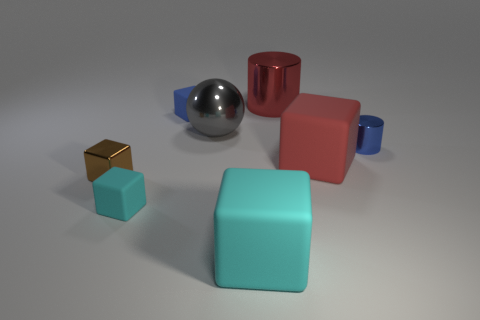Is the color of the shiny ball the same as the large rubber block that is behind the big cyan block?
Ensure brevity in your answer.  No. What number of cylinders are either cyan matte objects or red matte objects?
Your response must be concise. 0. There is a large matte cube left of the large red metal thing; what color is it?
Keep it short and to the point. Cyan. There is a tiny matte thing that is the same color as the tiny metal cylinder; what shape is it?
Offer a very short reply. Cube. How many blue objects have the same size as the sphere?
Your answer should be very brief. 0. Do the big rubber thing that is behind the small cyan cube and the small matte object in front of the brown object have the same shape?
Ensure brevity in your answer.  Yes. There is a big cube in front of the tiny rubber cube that is in front of the tiny metallic thing that is to the right of the big red shiny cylinder; what is it made of?
Give a very brief answer. Rubber. What shape is the blue metal thing that is the same size as the blue block?
Provide a succinct answer. Cylinder. Are there any small shiny things that have the same color as the tiny metallic cylinder?
Offer a terse response. No. How big is the blue cube?
Give a very brief answer. Small. 